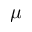<formula> <loc_0><loc_0><loc_500><loc_500>\mu</formula> 